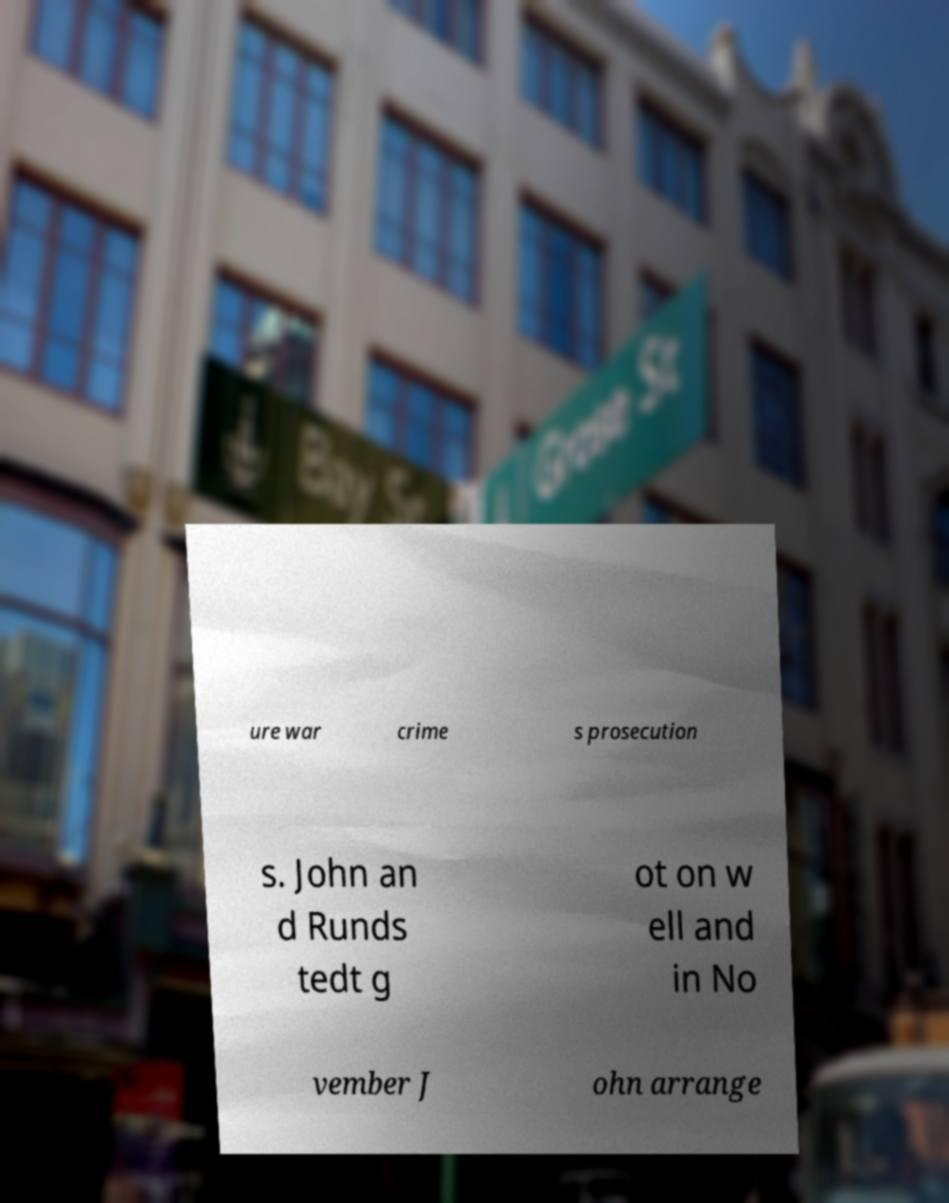Could you extract and type out the text from this image? ure war crime s prosecution s. John an d Runds tedt g ot on w ell and in No vember J ohn arrange 